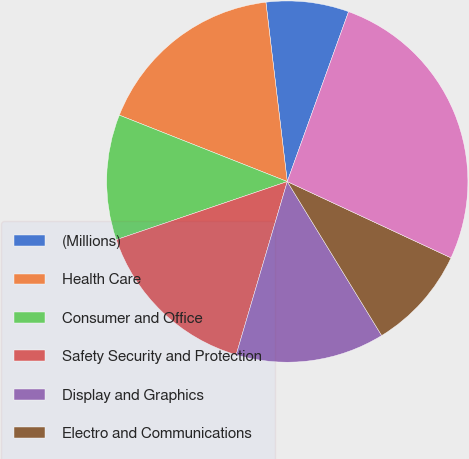Convert chart to OTSL. <chart><loc_0><loc_0><loc_500><loc_500><pie_chart><fcel>(Millions)<fcel>Health Care<fcel>Consumer and Office<fcel>Safety Security and Protection<fcel>Display and Graphics<fcel>Electro and Communications<fcel>Corporate and Unallocated<nl><fcel>7.4%<fcel>17.12%<fcel>11.21%<fcel>15.22%<fcel>13.32%<fcel>9.31%<fcel>26.43%<nl></chart> 